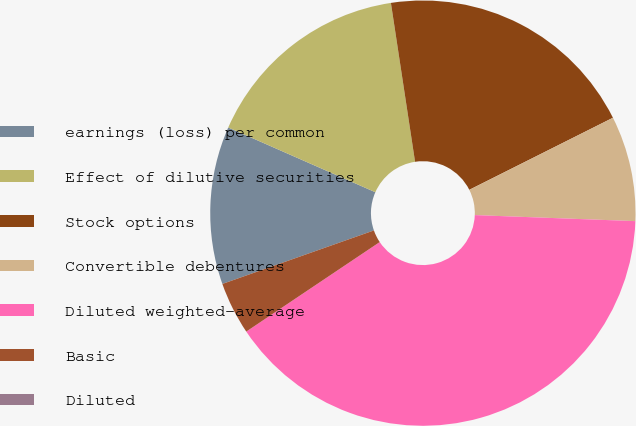Convert chart to OTSL. <chart><loc_0><loc_0><loc_500><loc_500><pie_chart><fcel>earnings (loss) per common<fcel>Effect of dilutive securities<fcel>Stock options<fcel>Convertible debentures<fcel>Diluted weighted-average<fcel>Basic<fcel>Diluted<nl><fcel>12.0%<fcel>16.0%<fcel>20.0%<fcel>8.0%<fcel>40.0%<fcel>4.0%<fcel>0.0%<nl></chart> 